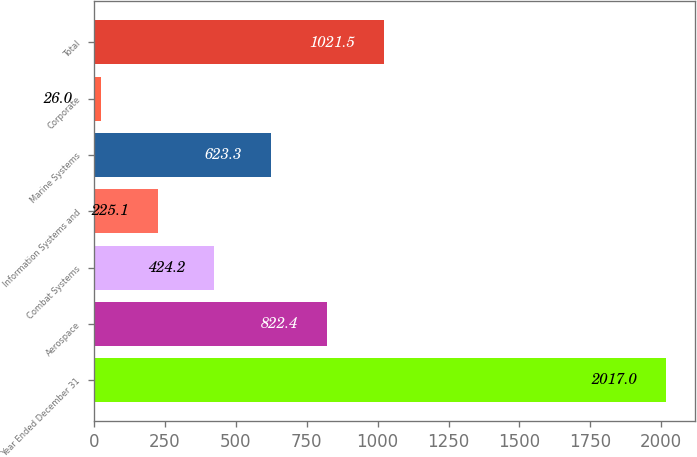<chart> <loc_0><loc_0><loc_500><loc_500><bar_chart><fcel>Year Ended December 31<fcel>Aerospace<fcel>Combat Systems<fcel>Information Systems and<fcel>Marine Systems<fcel>Corporate<fcel>Total<nl><fcel>2017<fcel>822.4<fcel>424.2<fcel>225.1<fcel>623.3<fcel>26<fcel>1021.5<nl></chart> 